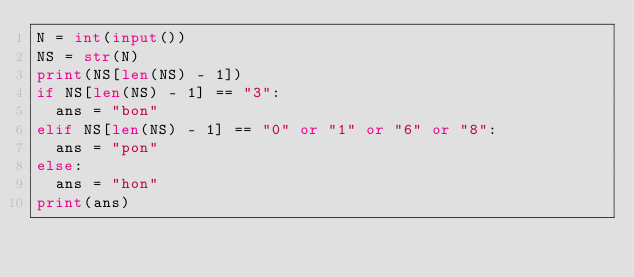Convert code to text. <code><loc_0><loc_0><loc_500><loc_500><_Python_>N = int(input())
NS = str(N)
print(NS[len(NS) - 1])
if NS[len(NS) - 1] == "3":
  ans = "bon"
elif NS[len(NS) - 1] == "0" or "1" or "6" or "8":
  ans = "pon"
else:
  ans = "hon"
print(ans)</code> 